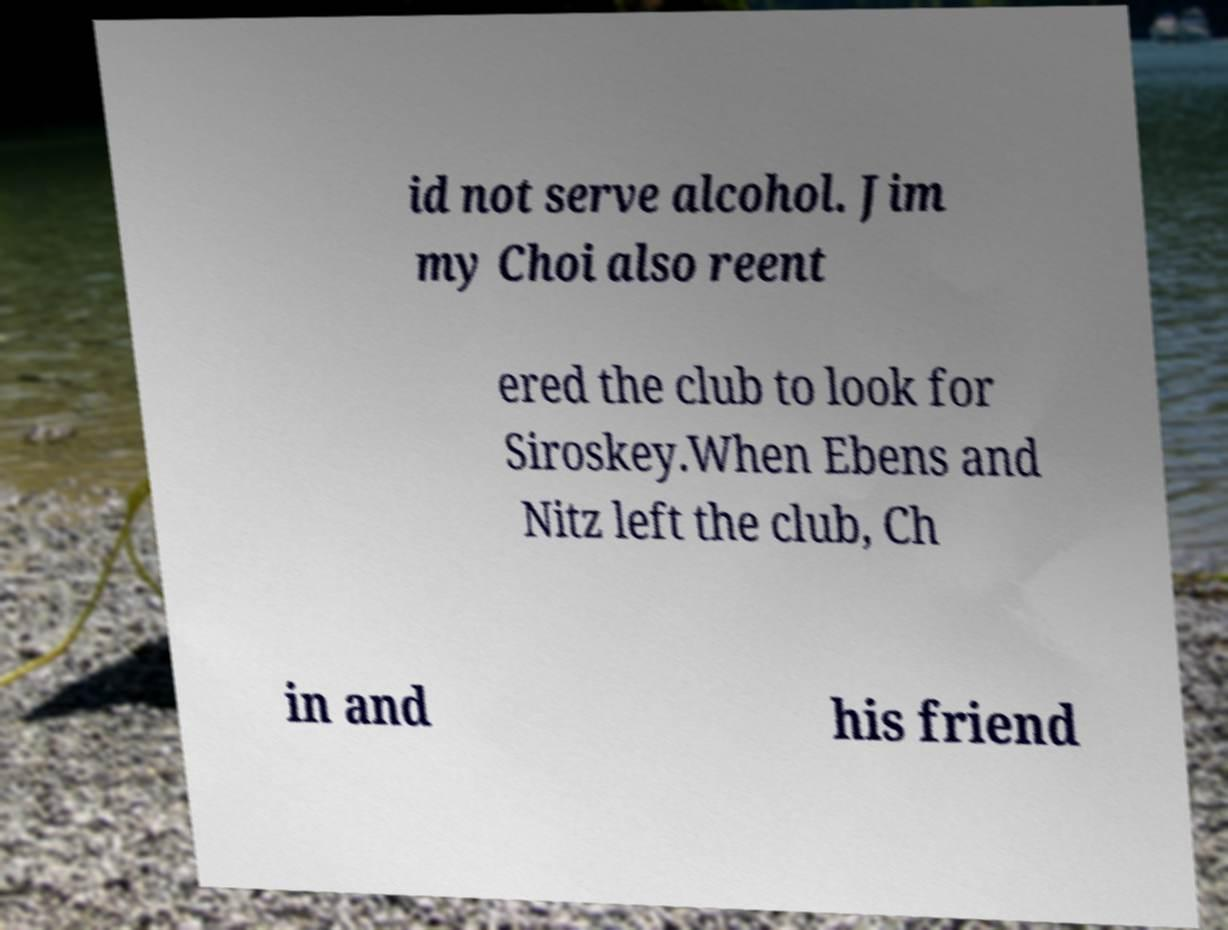Could you assist in decoding the text presented in this image and type it out clearly? id not serve alcohol. Jim my Choi also reent ered the club to look for Siroskey.When Ebens and Nitz left the club, Ch in and his friend 